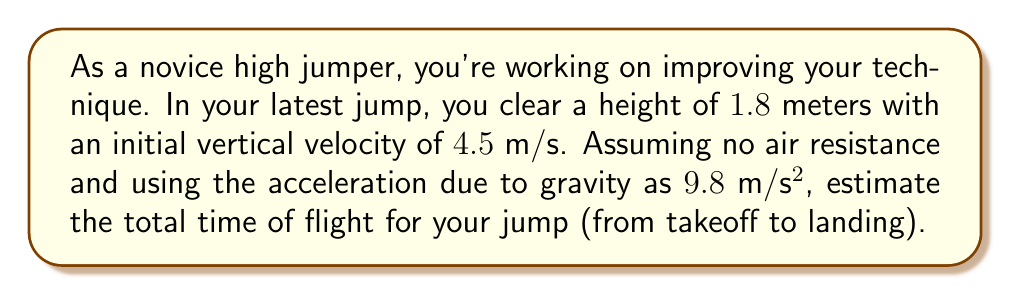Provide a solution to this math problem. To solve this problem, we need to use the equations of motion for a body under constant acceleration (gravity in this case). Let's break it down step-by-step:

1) The time of flight consists of two parts: time going up and time coming down. Due to the symmetry of the parabolic motion, these times are equal. So, we can find the time to reach the highest point and double it.

2) We can use the equation:

   $$v = v_0 + at$$

   Where $v$ is final velocity (0 at the highest point), $v_0$ is initial velocity (4.5 m/s), $a$ is acceleration (-9.8 m/s² for gravity, negative because it's opposing the motion), and $t$ is time.

3) Substituting these values:

   $$0 = 4.5 + (-9.8)t$$

4) Solving for $t$:

   $$t = \frac{4.5}{9.8} \approx 0.459 \text{ seconds}$$

5) This is the time to reach the highest point. The total time of flight is double this:

   $$\text{Total time} = 2 \times 0.459 \approx 0.918 \text{ seconds}$$

6) We can verify this using the equation for displacement:

   $$y = v_0t - \frac{1}{2}gt^2$$

   Where $y$ is the height cleared (1.8 m), $v_0$ is initial velocity (4.5 m/s), $g$ is acceleration due to gravity (9.8 m/s²), and $t$ is half the total time of flight (0.459 s).

7) Substituting these values:

   $$1.8 = 4.5(0.459) - \frac{1}{2}(9.8)(0.459)^2$$
   $$1.8 \approx 2.066 - 1.033 = 1.033$$

The slight discrepancy is due to rounding in our calculations.
Answer: The estimated total time of flight for the high jump is approximately 0.918 seconds. 